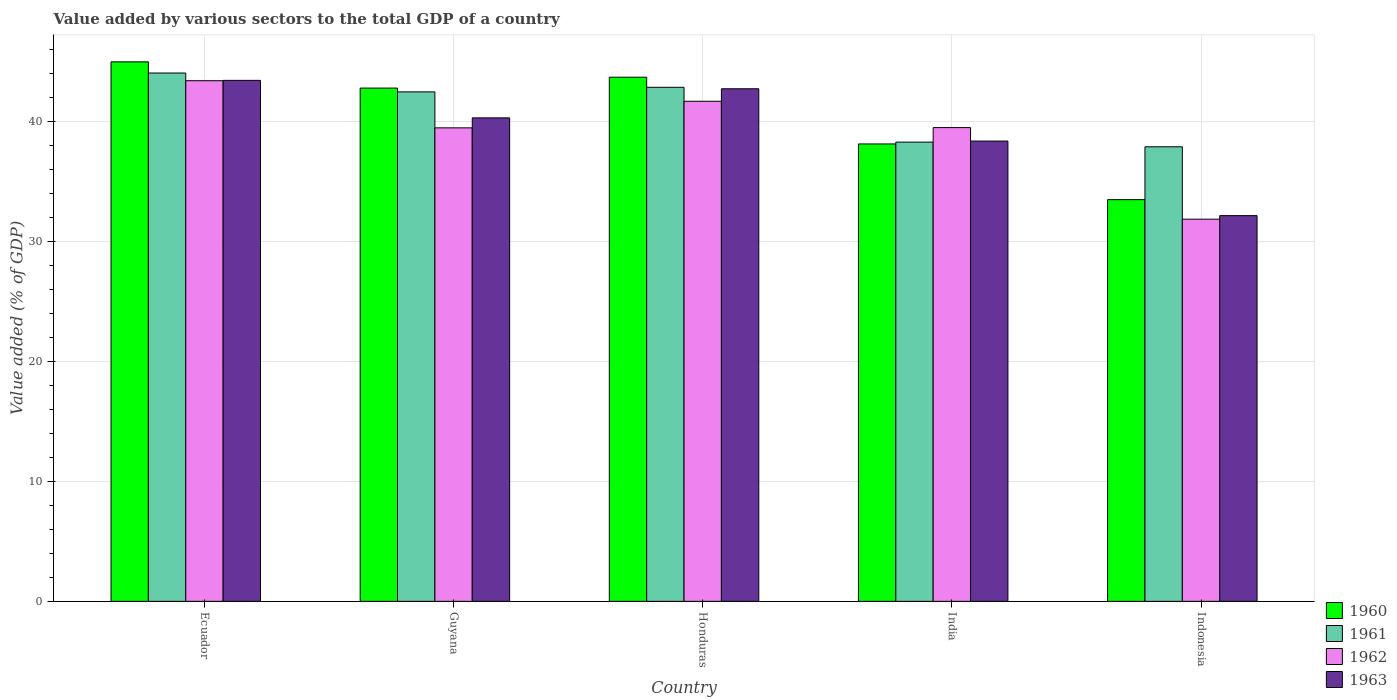How many different coloured bars are there?
Offer a very short reply. 4. Are the number of bars per tick equal to the number of legend labels?
Offer a very short reply. Yes. Are the number of bars on each tick of the X-axis equal?
Give a very brief answer. Yes. How many bars are there on the 5th tick from the left?
Ensure brevity in your answer.  4. How many bars are there on the 3rd tick from the right?
Your response must be concise. 4. What is the label of the 1st group of bars from the left?
Your response must be concise. Ecuador. What is the value added by various sectors to the total GDP in 1961 in Indonesia?
Provide a short and direct response. 37.9. Across all countries, what is the maximum value added by various sectors to the total GDP in 1960?
Make the answer very short. 44.99. Across all countries, what is the minimum value added by various sectors to the total GDP in 1963?
Provide a succinct answer. 32.16. In which country was the value added by various sectors to the total GDP in 1960 maximum?
Your response must be concise. Ecuador. What is the total value added by various sectors to the total GDP in 1962 in the graph?
Your answer should be compact. 195.96. What is the difference between the value added by various sectors to the total GDP in 1962 in Guyana and that in India?
Keep it short and to the point. -0.02. What is the difference between the value added by various sectors to the total GDP in 1961 in Indonesia and the value added by various sectors to the total GDP in 1962 in Ecuador?
Make the answer very short. -5.51. What is the average value added by various sectors to the total GDP in 1961 per country?
Your answer should be compact. 41.12. What is the difference between the value added by various sectors to the total GDP of/in 1961 and value added by various sectors to the total GDP of/in 1960 in Honduras?
Provide a short and direct response. -0.84. What is the ratio of the value added by various sectors to the total GDP in 1963 in Guyana to that in India?
Offer a terse response. 1.05. Is the difference between the value added by various sectors to the total GDP in 1961 in Honduras and India greater than the difference between the value added by various sectors to the total GDP in 1960 in Honduras and India?
Your answer should be compact. No. What is the difference between the highest and the second highest value added by various sectors to the total GDP in 1960?
Your answer should be very brief. -0.91. What is the difference between the highest and the lowest value added by various sectors to the total GDP in 1963?
Ensure brevity in your answer.  11.28. What does the 3rd bar from the left in India represents?
Your response must be concise. 1962. How many countries are there in the graph?
Your response must be concise. 5. Are the values on the major ticks of Y-axis written in scientific E-notation?
Offer a terse response. No. Does the graph contain any zero values?
Keep it short and to the point. No. Does the graph contain grids?
Give a very brief answer. Yes. Where does the legend appear in the graph?
Give a very brief answer. Bottom right. How many legend labels are there?
Offer a very short reply. 4. What is the title of the graph?
Keep it short and to the point. Value added by various sectors to the total GDP of a country. What is the label or title of the X-axis?
Keep it short and to the point. Country. What is the label or title of the Y-axis?
Your response must be concise. Value added (% of GDP). What is the Value added (% of GDP) of 1960 in Ecuador?
Your answer should be very brief. 44.99. What is the Value added (% of GDP) of 1961 in Ecuador?
Make the answer very short. 44.05. What is the Value added (% of GDP) of 1962 in Ecuador?
Make the answer very short. 43.41. What is the Value added (% of GDP) in 1963 in Ecuador?
Your response must be concise. 43.44. What is the Value added (% of GDP) in 1960 in Guyana?
Make the answer very short. 42.8. What is the Value added (% of GDP) of 1961 in Guyana?
Ensure brevity in your answer.  42.48. What is the Value added (% of GDP) of 1962 in Guyana?
Offer a terse response. 39.48. What is the Value added (% of GDP) of 1963 in Guyana?
Your response must be concise. 40.31. What is the Value added (% of GDP) of 1960 in Honduras?
Provide a succinct answer. 43.7. What is the Value added (% of GDP) of 1961 in Honduras?
Your response must be concise. 42.86. What is the Value added (% of GDP) of 1962 in Honduras?
Provide a short and direct response. 41.7. What is the Value added (% of GDP) in 1963 in Honduras?
Ensure brevity in your answer.  42.74. What is the Value added (% of GDP) of 1960 in India?
Keep it short and to the point. 38.14. What is the Value added (% of GDP) in 1961 in India?
Your response must be concise. 38.29. What is the Value added (% of GDP) in 1962 in India?
Provide a short and direct response. 39.5. What is the Value added (% of GDP) of 1963 in India?
Your answer should be compact. 38.38. What is the Value added (% of GDP) of 1960 in Indonesia?
Offer a terse response. 33.5. What is the Value added (% of GDP) of 1961 in Indonesia?
Give a very brief answer. 37.9. What is the Value added (% of GDP) of 1962 in Indonesia?
Provide a succinct answer. 31.87. What is the Value added (% of GDP) of 1963 in Indonesia?
Offer a very short reply. 32.16. Across all countries, what is the maximum Value added (% of GDP) in 1960?
Your answer should be very brief. 44.99. Across all countries, what is the maximum Value added (% of GDP) in 1961?
Offer a terse response. 44.05. Across all countries, what is the maximum Value added (% of GDP) in 1962?
Provide a succinct answer. 43.41. Across all countries, what is the maximum Value added (% of GDP) of 1963?
Your response must be concise. 43.44. Across all countries, what is the minimum Value added (% of GDP) in 1960?
Provide a succinct answer. 33.5. Across all countries, what is the minimum Value added (% of GDP) of 1961?
Your response must be concise. 37.9. Across all countries, what is the minimum Value added (% of GDP) in 1962?
Keep it short and to the point. 31.87. Across all countries, what is the minimum Value added (% of GDP) in 1963?
Offer a terse response. 32.16. What is the total Value added (% of GDP) in 1960 in the graph?
Provide a succinct answer. 203.12. What is the total Value added (% of GDP) of 1961 in the graph?
Offer a terse response. 205.59. What is the total Value added (% of GDP) in 1962 in the graph?
Keep it short and to the point. 195.96. What is the total Value added (% of GDP) in 1963 in the graph?
Your response must be concise. 197.04. What is the difference between the Value added (% of GDP) in 1960 in Ecuador and that in Guyana?
Provide a succinct answer. 2.19. What is the difference between the Value added (% of GDP) in 1961 in Ecuador and that in Guyana?
Offer a terse response. 1.57. What is the difference between the Value added (% of GDP) in 1962 in Ecuador and that in Guyana?
Your answer should be compact. 3.93. What is the difference between the Value added (% of GDP) of 1963 in Ecuador and that in Guyana?
Your response must be concise. 3.13. What is the difference between the Value added (% of GDP) in 1960 in Ecuador and that in Honduras?
Ensure brevity in your answer.  1.28. What is the difference between the Value added (% of GDP) in 1961 in Ecuador and that in Honduras?
Keep it short and to the point. 1.19. What is the difference between the Value added (% of GDP) in 1962 in Ecuador and that in Honduras?
Your answer should be compact. 1.72. What is the difference between the Value added (% of GDP) in 1963 in Ecuador and that in Honduras?
Make the answer very short. 0.7. What is the difference between the Value added (% of GDP) in 1960 in Ecuador and that in India?
Offer a very short reply. 6.85. What is the difference between the Value added (% of GDP) in 1961 in Ecuador and that in India?
Provide a short and direct response. 5.76. What is the difference between the Value added (% of GDP) of 1962 in Ecuador and that in India?
Your answer should be compact. 3.91. What is the difference between the Value added (% of GDP) of 1963 in Ecuador and that in India?
Keep it short and to the point. 5.06. What is the difference between the Value added (% of GDP) in 1960 in Ecuador and that in Indonesia?
Keep it short and to the point. 11.49. What is the difference between the Value added (% of GDP) in 1961 in Ecuador and that in Indonesia?
Give a very brief answer. 6.15. What is the difference between the Value added (% of GDP) of 1962 in Ecuador and that in Indonesia?
Your answer should be compact. 11.55. What is the difference between the Value added (% of GDP) of 1963 in Ecuador and that in Indonesia?
Your answer should be very brief. 11.28. What is the difference between the Value added (% of GDP) in 1960 in Guyana and that in Honduras?
Offer a terse response. -0.91. What is the difference between the Value added (% of GDP) of 1961 in Guyana and that in Honduras?
Offer a very short reply. -0.38. What is the difference between the Value added (% of GDP) in 1962 in Guyana and that in Honduras?
Make the answer very short. -2.21. What is the difference between the Value added (% of GDP) of 1963 in Guyana and that in Honduras?
Your response must be concise. -2.43. What is the difference between the Value added (% of GDP) in 1960 in Guyana and that in India?
Provide a short and direct response. 4.66. What is the difference between the Value added (% of GDP) of 1961 in Guyana and that in India?
Provide a short and direct response. 4.19. What is the difference between the Value added (% of GDP) in 1962 in Guyana and that in India?
Provide a succinct answer. -0.02. What is the difference between the Value added (% of GDP) of 1963 in Guyana and that in India?
Provide a succinct answer. 1.93. What is the difference between the Value added (% of GDP) in 1960 in Guyana and that in Indonesia?
Make the answer very short. 9.3. What is the difference between the Value added (% of GDP) of 1961 in Guyana and that in Indonesia?
Provide a short and direct response. 4.58. What is the difference between the Value added (% of GDP) of 1962 in Guyana and that in Indonesia?
Give a very brief answer. 7.62. What is the difference between the Value added (% of GDP) of 1963 in Guyana and that in Indonesia?
Your answer should be very brief. 8.15. What is the difference between the Value added (% of GDP) of 1960 in Honduras and that in India?
Your answer should be compact. 5.57. What is the difference between the Value added (% of GDP) in 1961 in Honduras and that in India?
Your answer should be very brief. 4.57. What is the difference between the Value added (% of GDP) in 1962 in Honduras and that in India?
Your response must be concise. 2.19. What is the difference between the Value added (% of GDP) in 1963 in Honduras and that in India?
Provide a succinct answer. 4.36. What is the difference between the Value added (% of GDP) of 1960 in Honduras and that in Indonesia?
Offer a very short reply. 10.21. What is the difference between the Value added (% of GDP) in 1961 in Honduras and that in Indonesia?
Give a very brief answer. 4.96. What is the difference between the Value added (% of GDP) of 1962 in Honduras and that in Indonesia?
Keep it short and to the point. 9.83. What is the difference between the Value added (% of GDP) of 1963 in Honduras and that in Indonesia?
Your answer should be compact. 10.58. What is the difference between the Value added (% of GDP) of 1960 in India and that in Indonesia?
Your answer should be very brief. 4.64. What is the difference between the Value added (% of GDP) of 1961 in India and that in Indonesia?
Offer a terse response. 0.39. What is the difference between the Value added (% of GDP) of 1962 in India and that in Indonesia?
Your answer should be compact. 7.64. What is the difference between the Value added (% of GDP) of 1963 in India and that in Indonesia?
Make the answer very short. 6.22. What is the difference between the Value added (% of GDP) of 1960 in Ecuador and the Value added (% of GDP) of 1961 in Guyana?
Provide a succinct answer. 2.5. What is the difference between the Value added (% of GDP) in 1960 in Ecuador and the Value added (% of GDP) in 1962 in Guyana?
Offer a terse response. 5.5. What is the difference between the Value added (% of GDP) of 1960 in Ecuador and the Value added (% of GDP) of 1963 in Guyana?
Provide a short and direct response. 4.67. What is the difference between the Value added (% of GDP) in 1961 in Ecuador and the Value added (% of GDP) in 1962 in Guyana?
Offer a very short reply. 4.57. What is the difference between the Value added (% of GDP) in 1961 in Ecuador and the Value added (% of GDP) in 1963 in Guyana?
Give a very brief answer. 3.74. What is the difference between the Value added (% of GDP) of 1962 in Ecuador and the Value added (% of GDP) of 1963 in Guyana?
Your answer should be compact. 3.1. What is the difference between the Value added (% of GDP) of 1960 in Ecuador and the Value added (% of GDP) of 1961 in Honduras?
Your response must be concise. 2.12. What is the difference between the Value added (% of GDP) in 1960 in Ecuador and the Value added (% of GDP) in 1962 in Honduras?
Your answer should be very brief. 3.29. What is the difference between the Value added (% of GDP) in 1960 in Ecuador and the Value added (% of GDP) in 1963 in Honduras?
Your answer should be compact. 2.24. What is the difference between the Value added (% of GDP) in 1961 in Ecuador and the Value added (% of GDP) in 1962 in Honduras?
Offer a very short reply. 2.36. What is the difference between the Value added (% of GDP) of 1961 in Ecuador and the Value added (% of GDP) of 1963 in Honduras?
Provide a short and direct response. 1.31. What is the difference between the Value added (% of GDP) of 1962 in Ecuador and the Value added (% of GDP) of 1963 in Honduras?
Keep it short and to the point. 0.67. What is the difference between the Value added (% of GDP) in 1960 in Ecuador and the Value added (% of GDP) in 1961 in India?
Keep it short and to the point. 6.69. What is the difference between the Value added (% of GDP) of 1960 in Ecuador and the Value added (% of GDP) of 1962 in India?
Your answer should be compact. 5.48. What is the difference between the Value added (% of GDP) in 1960 in Ecuador and the Value added (% of GDP) in 1963 in India?
Your answer should be compact. 6.6. What is the difference between the Value added (% of GDP) of 1961 in Ecuador and the Value added (% of GDP) of 1962 in India?
Your answer should be compact. 4.55. What is the difference between the Value added (% of GDP) of 1961 in Ecuador and the Value added (% of GDP) of 1963 in India?
Provide a short and direct response. 5.67. What is the difference between the Value added (% of GDP) in 1962 in Ecuador and the Value added (% of GDP) in 1963 in India?
Your answer should be compact. 5.03. What is the difference between the Value added (% of GDP) of 1960 in Ecuador and the Value added (% of GDP) of 1961 in Indonesia?
Your answer should be very brief. 7.08. What is the difference between the Value added (% of GDP) of 1960 in Ecuador and the Value added (% of GDP) of 1962 in Indonesia?
Make the answer very short. 13.12. What is the difference between the Value added (% of GDP) of 1960 in Ecuador and the Value added (% of GDP) of 1963 in Indonesia?
Keep it short and to the point. 12.82. What is the difference between the Value added (% of GDP) of 1961 in Ecuador and the Value added (% of GDP) of 1962 in Indonesia?
Provide a succinct answer. 12.19. What is the difference between the Value added (% of GDP) in 1961 in Ecuador and the Value added (% of GDP) in 1963 in Indonesia?
Keep it short and to the point. 11.89. What is the difference between the Value added (% of GDP) of 1962 in Ecuador and the Value added (% of GDP) of 1963 in Indonesia?
Your answer should be very brief. 11.25. What is the difference between the Value added (% of GDP) of 1960 in Guyana and the Value added (% of GDP) of 1961 in Honduras?
Make the answer very short. -0.07. What is the difference between the Value added (% of GDP) in 1960 in Guyana and the Value added (% of GDP) in 1963 in Honduras?
Offer a very short reply. 0.06. What is the difference between the Value added (% of GDP) of 1961 in Guyana and the Value added (% of GDP) of 1962 in Honduras?
Make the answer very short. 0.78. What is the difference between the Value added (% of GDP) in 1961 in Guyana and the Value added (% of GDP) in 1963 in Honduras?
Offer a very short reply. -0.26. What is the difference between the Value added (% of GDP) of 1962 in Guyana and the Value added (% of GDP) of 1963 in Honduras?
Provide a succinct answer. -3.26. What is the difference between the Value added (% of GDP) of 1960 in Guyana and the Value added (% of GDP) of 1961 in India?
Keep it short and to the point. 4.5. What is the difference between the Value added (% of GDP) of 1960 in Guyana and the Value added (% of GDP) of 1962 in India?
Provide a short and direct response. 3.29. What is the difference between the Value added (% of GDP) in 1960 in Guyana and the Value added (% of GDP) in 1963 in India?
Offer a terse response. 4.42. What is the difference between the Value added (% of GDP) in 1961 in Guyana and the Value added (% of GDP) in 1962 in India?
Offer a very short reply. 2.98. What is the difference between the Value added (% of GDP) in 1961 in Guyana and the Value added (% of GDP) in 1963 in India?
Ensure brevity in your answer.  4.1. What is the difference between the Value added (% of GDP) of 1962 in Guyana and the Value added (% of GDP) of 1963 in India?
Keep it short and to the point. 1.1. What is the difference between the Value added (% of GDP) of 1960 in Guyana and the Value added (% of GDP) of 1961 in Indonesia?
Ensure brevity in your answer.  4.89. What is the difference between the Value added (% of GDP) of 1960 in Guyana and the Value added (% of GDP) of 1962 in Indonesia?
Give a very brief answer. 10.93. What is the difference between the Value added (% of GDP) in 1960 in Guyana and the Value added (% of GDP) in 1963 in Indonesia?
Your answer should be compact. 10.64. What is the difference between the Value added (% of GDP) of 1961 in Guyana and the Value added (% of GDP) of 1962 in Indonesia?
Ensure brevity in your answer.  10.61. What is the difference between the Value added (% of GDP) in 1961 in Guyana and the Value added (% of GDP) in 1963 in Indonesia?
Give a very brief answer. 10.32. What is the difference between the Value added (% of GDP) of 1962 in Guyana and the Value added (% of GDP) of 1963 in Indonesia?
Offer a terse response. 7.32. What is the difference between the Value added (% of GDP) in 1960 in Honduras and the Value added (% of GDP) in 1961 in India?
Give a very brief answer. 5.41. What is the difference between the Value added (% of GDP) of 1960 in Honduras and the Value added (% of GDP) of 1962 in India?
Offer a very short reply. 4.2. What is the difference between the Value added (% of GDP) in 1960 in Honduras and the Value added (% of GDP) in 1963 in India?
Give a very brief answer. 5.32. What is the difference between the Value added (% of GDP) in 1961 in Honduras and the Value added (% of GDP) in 1962 in India?
Offer a terse response. 3.36. What is the difference between the Value added (% of GDP) of 1961 in Honduras and the Value added (% of GDP) of 1963 in India?
Ensure brevity in your answer.  4.48. What is the difference between the Value added (% of GDP) of 1962 in Honduras and the Value added (% of GDP) of 1963 in India?
Make the answer very short. 3.32. What is the difference between the Value added (% of GDP) in 1960 in Honduras and the Value added (% of GDP) in 1961 in Indonesia?
Your response must be concise. 5.8. What is the difference between the Value added (% of GDP) of 1960 in Honduras and the Value added (% of GDP) of 1962 in Indonesia?
Your response must be concise. 11.84. What is the difference between the Value added (% of GDP) of 1960 in Honduras and the Value added (% of GDP) of 1963 in Indonesia?
Make the answer very short. 11.54. What is the difference between the Value added (% of GDP) in 1961 in Honduras and the Value added (% of GDP) in 1962 in Indonesia?
Offer a terse response. 11. What is the difference between the Value added (% of GDP) in 1961 in Honduras and the Value added (% of GDP) in 1963 in Indonesia?
Your answer should be very brief. 10.7. What is the difference between the Value added (% of GDP) in 1962 in Honduras and the Value added (% of GDP) in 1963 in Indonesia?
Provide a short and direct response. 9.54. What is the difference between the Value added (% of GDP) of 1960 in India and the Value added (% of GDP) of 1961 in Indonesia?
Your answer should be very brief. 0.24. What is the difference between the Value added (% of GDP) in 1960 in India and the Value added (% of GDP) in 1962 in Indonesia?
Make the answer very short. 6.27. What is the difference between the Value added (% of GDP) in 1960 in India and the Value added (% of GDP) in 1963 in Indonesia?
Your answer should be compact. 5.98. What is the difference between the Value added (% of GDP) in 1961 in India and the Value added (% of GDP) in 1962 in Indonesia?
Make the answer very short. 6.43. What is the difference between the Value added (% of GDP) in 1961 in India and the Value added (% of GDP) in 1963 in Indonesia?
Provide a succinct answer. 6.13. What is the difference between the Value added (% of GDP) of 1962 in India and the Value added (% of GDP) of 1963 in Indonesia?
Provide a succinct answer. 7.34. What is the average Value added (% of GDP) of 1960 per country?
Provide a succinct answer. 40.62. What is the average Value added (% of GDP) in 1961 per country?
Provide a succinct answer. 41.12. What is the average Value added (% of GDP) of 1962 per country?
Your answer should be very brief. 39.19. What is the average Value added (% of GDP) of 1963 per country?
Your answer should be very brief. 39.41. What is the difference between the Value added (% of GDP) in 1960 and Value added (% of GDP) in 1961 in Ecuador?
Offer a very short reply. 0.93. What is the difference between the Value added (% of GDP) in 1960 and Value added (% of GDP) in 1962 in Ecuador?
Offer a terse response. 1.57. What is the difference between the Value added (% of GDP) of 1960 and Value added (% of GDP) of 1963 in Ecuador?
Provide a short and direct response. 1.54. What is the difference between the Value added (% of GDP) in 1961 and Value added (% of GDP) in 1962 in Ecuador?
Your answer should be very brief. 0.64. What is the difference between the Value added (% of GDP) in 1961 and Value added (% of GDP) in 1963 in Ecuador?
Your response must be concise. 0.61. What is the difference between the Value added (% of GDP) of 1962 and Value added (% of GDP) of 1963 in Ecuador?
Offer a very short reply. -0.03. What is the difference between the Value added (% of GDP) of 1960 and Value added (% of GDP) of 1961 in Guyana?
Give a very brief answer. 0.32. What is the difference between the Value added (% of GDP) in 1960 and Value added (% of GDP) in 1962 in Guyana?
Ensure brevity in your answer.  3.31. What is the difference between the Value added (% of GDP) of 1960 and Value added (% of GDP) of 1963 in Guyana?
Ensure brevity in your answer.  2.48. What is the difference between the Value added (% of GDP) of 1961 and Value added (% of GDP) of 1962 in Guyana?
Give a very brief answer. 3. What is the difference between the Value added (% of GDP) of 1961 and Value added (% of GDP) of 1963 in Guyana?
Your answer should be compact. 2.17. What is the difference between the Value added (% of GDP) in 1962 and Value added (% of GDP) in 1963 in Guyana?
Provide a short and direct response. -0.83. What is the difference between the Value added (% of GDP) in 1960 and Value added (% of GDP) in 1961 in Honduras?
Your answer should be compact. 0.84. What is the difference between the Value added (% of GDP) of 1960 and Value added (% of GDP) of 1962 in Honduras?
Ensure brevity in your answer.  2.01. What is the difference between the Value added (% of GDP) of 1960 and Value added (% of GDP) of 1963 in Honduras?
Make the answer very short. 0.96. What is the difference between the Value added (% of GDP) of 1961 and Value added (% of GDP) of 1962 in Honduras?
Offer a very short reply. 1.17. What is the difference between the Value added (% of GDP) in 1961 and Value added (% of GDP) in 1963 in Honduras?
Provide a succinct answer. 0.12. What is the difference between the Value added (% of GDP) in 1962 and Value added (% of GDP) in 1963 in Honduras?
Keep it short and to the point. -1.04. What is the difference between the Value added (% of GDP) of 1960 and Value added (% of GDP) of 1961 in India?
Offer a very short reply. -0.15. What is the difference between the Value added (% of GDP) in 1960 and Value added (% of GDP) in 1962 in India?
Offer a very short reply. -1.36. What is the difference between the Value added (% of GDP) of 1960 and Value added (% of GDP) of 1963 in India?
Offer a terse response. -0.24. What is the difference between the Value added (% of GDP) of 1961 and Value added (% of GDP) of 1962 in India?
Keep it short and to the point. -1.21. What is the difference between the Value added (% of GDP) in 1961 and Value added (% of GDP) in 1963 in India?
Make the answer very short. -0.09. What is the difference between the Value added (% of GDP) of 1962 and Value added (% of GDP) of 1963 in India?
Offer a very short reply. 1.12. What is the difference between the Value added (% of GDP) in 1960 and Value added (% of GDP) in 1961 in Indonesia?
Your answer should be very brief. -4.41. What is the difference between the Value added (% of GDP) in 1960 and Value added (% of GDP) in 1962 in Indonesia?
Keep it short and to the point. 1.63. What is the difference between the Value added (% of GDP) of 1960 and Value added (% of GDP) of 1963 in Indonesia?
Keep it short and to the point. 1.33. What is the difference between the Value added (% of GDP) of 1961 and Value added (% of GDP) of 1962 in Indonesia?
Your response must be concise. 6.04. What is the difference between the Value added (% of GDP) in 1961 and Value added (% of GDP) in 1963 in Indonesia?
Offer a terse response. 5.74. What is the difference between the Value added (% of GDP) of 1962 and Value added (% of GDP) of 1963 in Indonesia?
Provide a succinct answer. -0.3. What is the ratio of the Value added (% of GDP) in 1960 in Ecuador to that in Guyana?
Provide a short and direct response. 1.05. What is the ratio of the Value added (% of GDP) in 1962 in Ecuador to that in Guyana?
Give a very brief answer. 1.1. What is the ratio of the Value added (% of GDP) of 1963 in Ecuador to that in Guyana?
Your answer should be very brief. 1.08. What is the ratio of the Value added (% of GDP) of 1960 in Ecuador to that in Honduras?
Offer a very short reply. 1.03. What is the ratio of the Value added (% of GDP) of 1961 in Ecuador to that in Honduras?
Keep it short and to the point. 1.03. What is the ratio of the Value added (% of GDP) in 1962 in Ecuador to that in Honduras?
Your answer should be very brief. 1.04. What is the ratio of the Value added (% of GDP) in 1963 in Ecuador to that in Honduras?
Ensure brevity in your answer.  1.02. What is the ratio of the Value added (% of GDP) in 1960 in Ecuador to that in India?
Your answer should be very brief. 1.18. What is the ratio of the Value added (% of GDP) in 1961 in Ecuador to that in India?
Provide a short and direct response. 1.15. What is the ratio of the Value added (% of GDP) of 1962 in Ecuador to that in India?
Offer a terse response. 1.1. What is the ratio of the Value added (% of GDP) of 1963 in Ecuador to that in India?
Keep it short and to the point. 1.13. What is the ratio of the Value added (% of GDP) of 1960 in Ecuador to that in Indonesia?
Provide a short and direct response. 1.34. What is the ratio of the Value added (% of GDP) of 1961 in Ecuador to that in Indonesia?
Provide a succinct answer. 1.16. What is the ratio of the Value added (% of GDP) of 1962 in Ecuador to that in Indonesia?
Your answer should be very brief. 1.36. What is the ratio of the Value added (% of GDP) of 1963 in Ecuador to that in Indonesia?
Your answer should be compact. 1.35. What is the ratio of the Value added (% of GDP) of 1960 in Guyana to that in Honduras?
Keep it short and to the point. 0.98. What is the ratio of the Value added (% of GDP) of 1962 in Guyana to that in Honduras?
Ensure brevity in your answer.  0.95. What is the ratio of the Value added (% of GDP) in 1963 in Guyana to that in Honduras?
Give a very brief answer. 0.94. What is the ratio of the Value added (% of GDP) of 1960 in Guyana to that in India?
Provide a short and direct response. 1.12. What is the ratio of the Value added (% of GDP) in 1961 in Guyana to that in India?
Offer a very short reply. 1.11. What is the ratio of the Value added (% of GDP) in 1963 in Guyana to that in India?
Offer a terse response. 1.05. What is the ratio of the Value added (% of GDP) in 1960 in Guyana to that in Indonesia?
Your answer should be very brief. 1.28. What is the ratio of the Value added (% of GDP) of 1961 in Guyana to that in Indonesia?
Give a very brief answer. 1.12. What is the ratio of the Value added (% of GDP) of 1962 in Guyana to that in Indonesia?
Make the answer very short. 1.24. What is the ratio of the Value added (% of GDP) in 1963 in Guyana to that in Indonesia?
Provide a short and direct response. 1.25. What is the ratio of the Value added (% of GDP) in 1960 in Honduras to that in India?
Your answer should be compact. 1.15. What is the ratio of the Value added (% of GDP) of 1961 in Honduras to that in India?
Provide a succinct answer. 1.12. What is the ratio of the Value added (% of GDP) in 1962 in Honduras to that in India?
Your answer should be compact. 1.06. What is the ratio of the Value added (% of GDP) in 1963 in Honduras to that in India?
Offer a very short reply. 1.11. What is the ratio of the Value added (% of GDP) in 1960 in Honduras to that in Indonesia?
Provide a short and direct response. 1.3. What is the ratio of the Value added (% of GDP) in 1961 in Honduras to that in Indonesia?
Your answer should be compact. 1.13. What is the ratio of the Value added (% of GDP) of 1962 in Honduras to that in Indonesia?
Your response must be concise. 1.31. What is the ratio of the Value added (% of GDP) in 1963 in Honduras to that in Indonesia?
Give a very brief answer. 1.33. What is the ratio of the Value added (% of GDP) in 1960 in India to that in Indonesia?
Keep it short and to the point. 1.14. What is the ratio of the Value added (% of GDP) in 1961 in India to that in Indonesia?
Your answer should be very brief. 1.01. What is the ratio of the Value added (% of GDP) of 1962 in India to that in Indonesia?
Your response must be concise. 1.24. What is the ratio of the Value added (% of GDP) in 1963 in India to that in Indonesia?
Ensure brevity in your answer.  1.19. What is the difference between the highest and the second highest Value added (% of GDP) of 1960?
Ensure brevity in your answer.  1.28. What is the difference between the highest and the second highest Value added (% of GDP) of 1961?
Make the answer very short. 1.19. What is the difference between the highest and the second highest Value added (% of GDP) of 1962?
Your response must be concise. 1.72. What is the difference between the highest and the second highest Value added (% of GDP) in 1963?
Give a very brief answer. 0.7. What is the difference between the highest and the lowest Value added (% of GDP) of 1960?
Keep it short and to the point. 11.49. What is the difference between the highest and the lowest Value added (% of GDP) of 1961?
Your answer should be very brief. 6.15. What is the difference between the highest and the lowest Value added (% of GDP) in 1962?
Provide a short and direct response. 11.55. What is the difference between the highest and the lowest Value added (% of GDP) of 1963?
Provide a short and direct response. 11.28. 